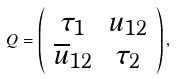Convert formula to latex. <formula><loc_0><loc_0><loc_500><loc_500>Q = \left ( \begin{array} { c c } \tau _ { 1 } & u _ { 1 2 } \\ \overline { u } _ { 1 2 } & \tau _ { 2 } \\ \end{array} \right ) ,</formula> 